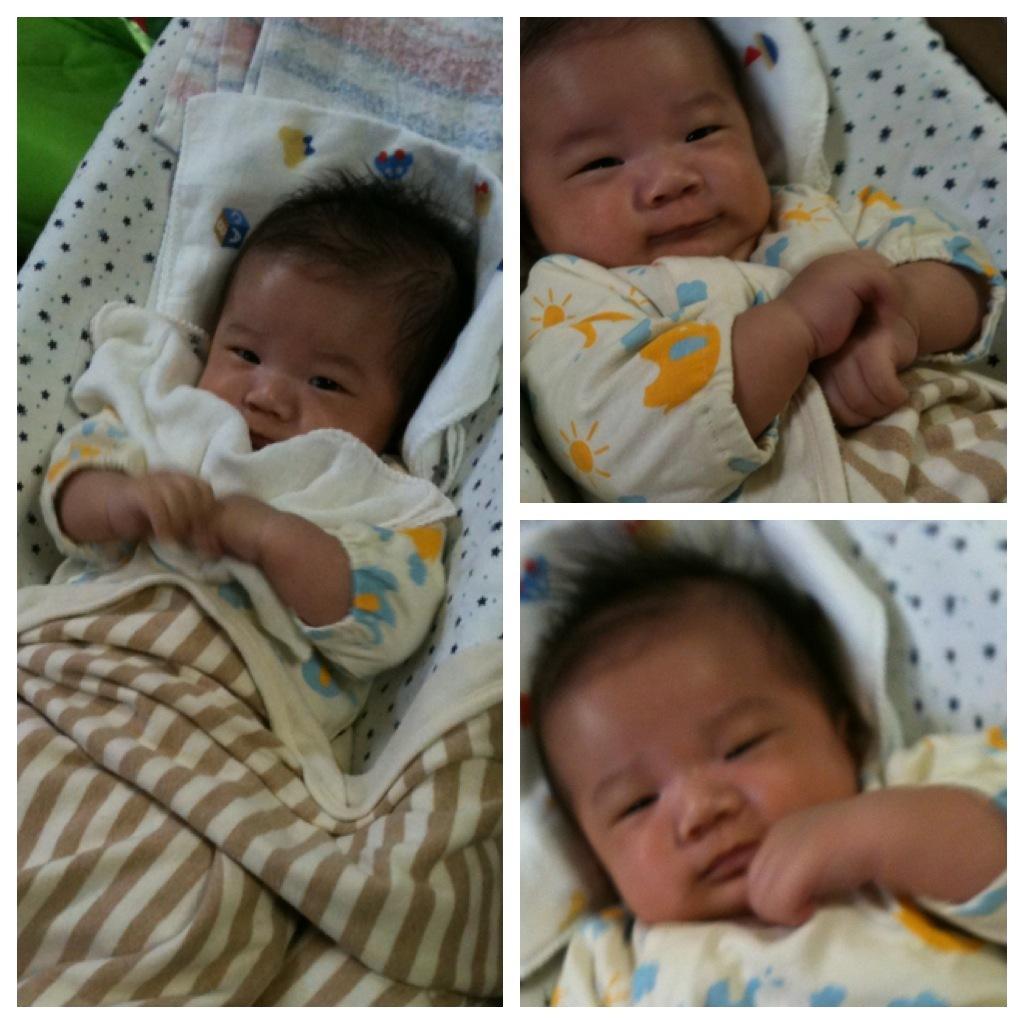In one or two sentences, can you explain what this image depicts? A collage picture of the same baby. This baby is laying on the cloth surface. Above this baby there is a baby blanket. 